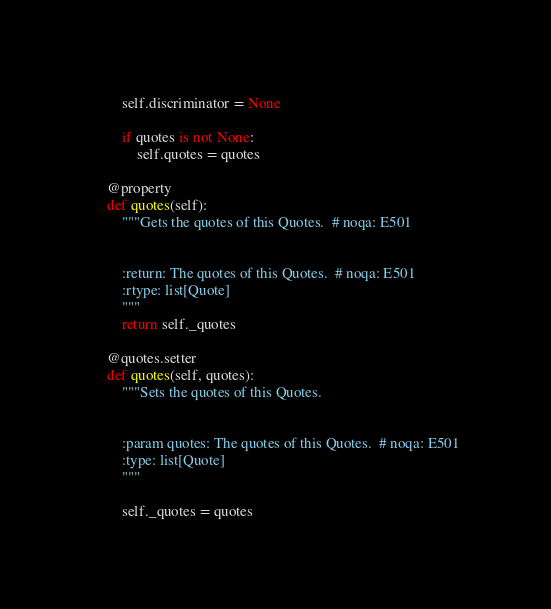Convert code to text. <code><loc_0><loc_0><loc_500><loc_500><_Python_>        self.discriminator = None

        if quotes is not None:
            self.quotes = quotes

    @property
    def quotes(self):
        """Gets the quotes of this Quotes.  # noqa: E501


        :return: The quotes of this Quotes.  # noqa: E501
        :rtype: list[Quote]
        """
        return self._quotes

    @quotes.setter
    def quotes(self, quotes):
        """Sets the quotes of this Quotes.


        :param quotes: The quotes of this Quotes.  # noqa: E501
        :type: list[Quote]
        """

        self._quotes = quotes
</code> 